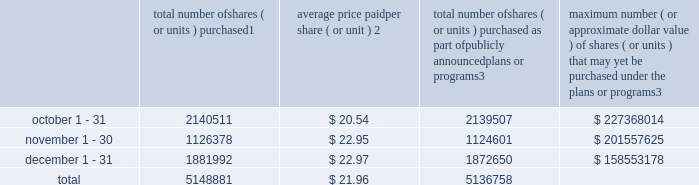Transfer agent and registrar for common stock the transfer agent and registrar for our common stock is : computershare shareowner services llc 480 washington boulevard 29th floor jersey city , new jersey 07310 telephone : ( 877 ) 363-6398 sales of unregistered securities not applicable .
Repurchase of equity securities the table provides information regarding our purchases of our equity securities during the period from october 1 , 2015 to december 31 , 2015 .
Total number of shares ( or units ) purchased 1 average price paid per share ( or unit ) 2 total number of shares ( or units ) purchased as part of publicly announced plans or programs 3 maximum number ( or approximate dollar value ) of shares ( or units ) that may yet be purchased under the plans or programs 3 .
1 included shares of our common stock , par value $ 0.10 per share , withheld under the terms of grants under employee stock-based compensation plans to offset tax withholding obligations that occurred upon vesting and release of restricted shares ( the 201cwithheld shares 201d ) .
We repurchased 1004 withheld shares in october 2015 , 1777 withheld shares in november 2015 and 9342 withheld shares in december 2015 .
2 the average price per share for each of the months in the fiscal quarter and for the three-month period was calculated by dividing the sum of the applicable period of the aggregate value of the tax withholding obligations and the aggregate amount we paid for shares acquired under our stock repurchase program , described in note 5 to the consolidated financial statements , by the sum of the number of withheld shares and the number of shares acquired in our stock repurchase program .
3 in february 2015 , the board authorized a share repurchase program to repurchase from time to time up to $ 300.0 million , excluding fees , of our common stock ( the 201c2015 share repurchase program 201d ) .
On february 12 , 2016 , we announced that our board had approved a new share repurchase program to repurchase from time to time up to $ 300.0 million , excluding fees , of our common stock .
The new authorization is in addition to any amounts remaining for repurchase under the 2015 share repurchase program .
There is no expiration date associated with the share repurchase programs. .
What is the total cash used for the repurchase of shares during the last three months of the year , ( in millions ) ? 
Computations: ((5148881 * 21.96) / 1000000)
Answer: 113.06943. Transfer agent and registrar for common stock the transfer agent and registrar for our common stock is : computershare shareowner services llc 480 washington boulevard 29th floor jersey city , new jersey 07310 telephone : ( 877 ) 363-6398 sales of unregistered securities not applicable .
Repurchase of equity securities the table provides information regarding our purchases of our equity securities during the period from october 1 , 2015 to december 31 , 2015 .
Total number of shares ( or units ) purchased 1 average price paid per share ( or unit ) 2 total number of shares ( or units ) purchased as part of publicly announced plans or programs 3 maximum number ( or approximate dollar value ) of shares ( or units ) that may yet be purchased under the plans or programs 3 .
1 included shares of our common stock , par value $ 0.10 per share , withheld under the terms of grants under employee stock-based compensation plans to offset tax withholding obligations that occurred upon vesting and release of restricted shares ( the 201cwithheld shares 201d ) .
We repurchased 1004 withheld shares in october 2015 , 1777 withheld shares in november 2015 and 9342 withheld shares in december 2015 .
2 the average price per share for each of the months in the fiscal quarter and for the three-month period was calculated by dividing the sum of the applicable period of the aggregate value of the tax withholding obligations and the aggregate amount we paid for shares acquired under our stock repurchase program , described in note 5 to the consolidated financial statements , by the sum of the number of withheld shares and the number of shares acquired in our stock repurchase program .
3 in february 2015 , the board authorized a share repurchase program to repurchase from time to time up to $ 300.0 million , excluding fees , of our common stock ( the 201c2015 share repurchase program 201d ) .
On february 12 , 2016 , we announced that our board had approved a new share repurchase program to repurchase from time to time up to $ 300.0 million , excluding fees , of our common stock .
The new authorization is in addition to any amounts remaining for repurchase under the 2015 share repurchase program .
There is no expiration date associated with the share repurchase programs. .
What is the total cash used for the repurchase of shares during october , ( in millions ) ? 
Computations: ((2140511 * 20.54) / 1000000)
Answer: 43.9661. 